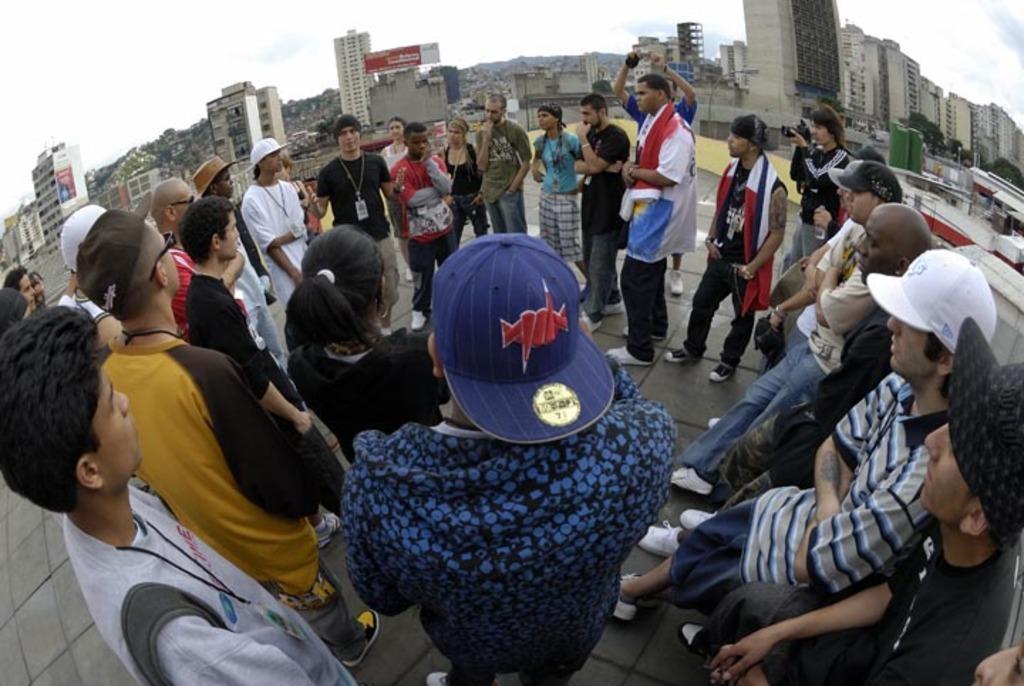Please provide a concise description of this image. In this image we can see some people standing and there are two persons holding cameras. We can see some buildings and trees in the background and at the top we can see the sky. 